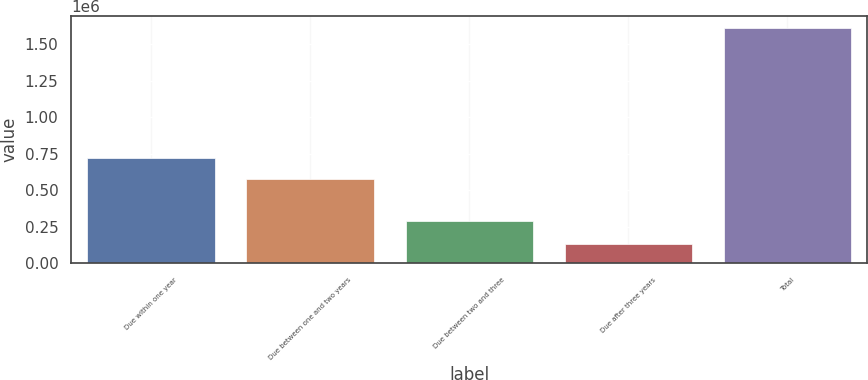Convert chart. <chart><loc_0><loc_0><loc_500><loc_500><bar_chart><fcel>Due within one year<fcel>Due between one and two years<fcel>Due between two and three<fcel>Due after three years<fcel>Total<nl><fcel>722499<fcel>574554<fcel>289033<fcel>132061<fcel>1.61152e+06<nl></chart> 